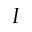Convert formula to latex. <formula><loc_0><loc_0><loc_500><loc_500>I</formula> 